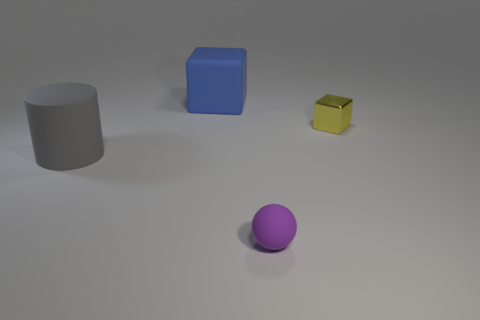Add 1 yellow cubes. How many objects exist? 5 Subtract 1 spheres. How many spheres are left? 0 Subtract all spheres. How many objects are left? 3 Add 3 purple matte balls. How many purple matte balls exist? 4 Subtract 0 green spheres. How many objects are left? 4 Subtract all yellow balls. Subtract all blue cubes. How many balls are left? 1 Subtract all blue rubber things. Subtract all cylinders. How many objects are left? 2 Add 2 gray matte cylinders. How many gray matte cylinders are left? 3 